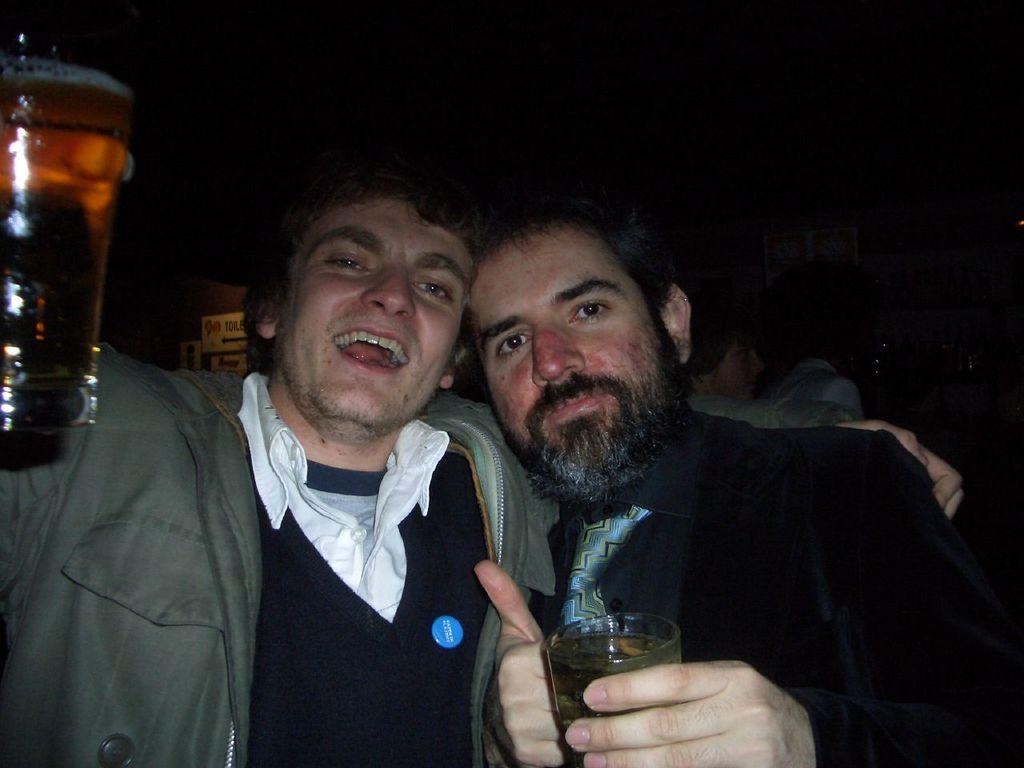How many men are visible in the image? There are two men standing in the image. What are the men holding in their hands? The men are holding beverage glasses. Are there any other people visible in the image? Yes, there are a few people behind the two men. What can be observed about the lighting in the image? The rest of the image is dark. What type of slope can be seen in the image? There is no slope present in the image. How many rings are visible on the fingers of the men in the image? There is no information about rings on the men's fingers in the image. 